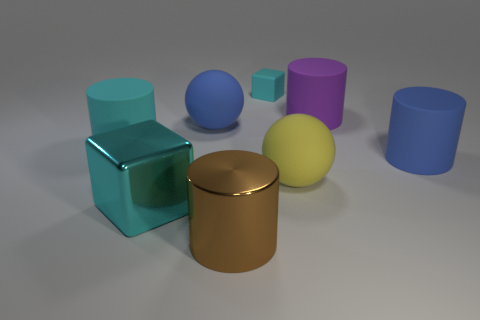Subtract all large cyan matte cylinders. How many cylinders are left? 3 Subtract 2 cylinders. How many cylinders are left? 2 Subtract all cyan cylinders. How many cylinders are left? 3 Add 1 big green metallic blocks. How many objects exist? 9 Subtract all cyan cylinders. Subtract all cyan cubes. How many cylinders are left? 3 Subtract 0 red balls. How many objects are left? 8 Subtract all blocks. How many objects are left? 6 Subtract all big purple cubes. Subtract all yellow rubber spheres. How many objects are left? 7 Add 4 large metal cylinders. How many large metal cylinders are left? 5 Add 2 cylinders. How many cylinders exist? 6 